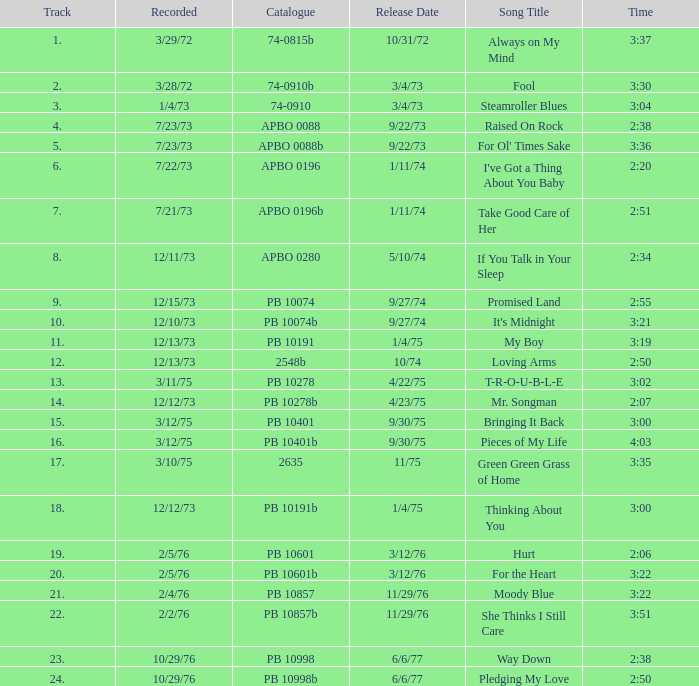Name the catalogue that has tracks less than 13 and the release date of 10/31/72 74-0815b. 